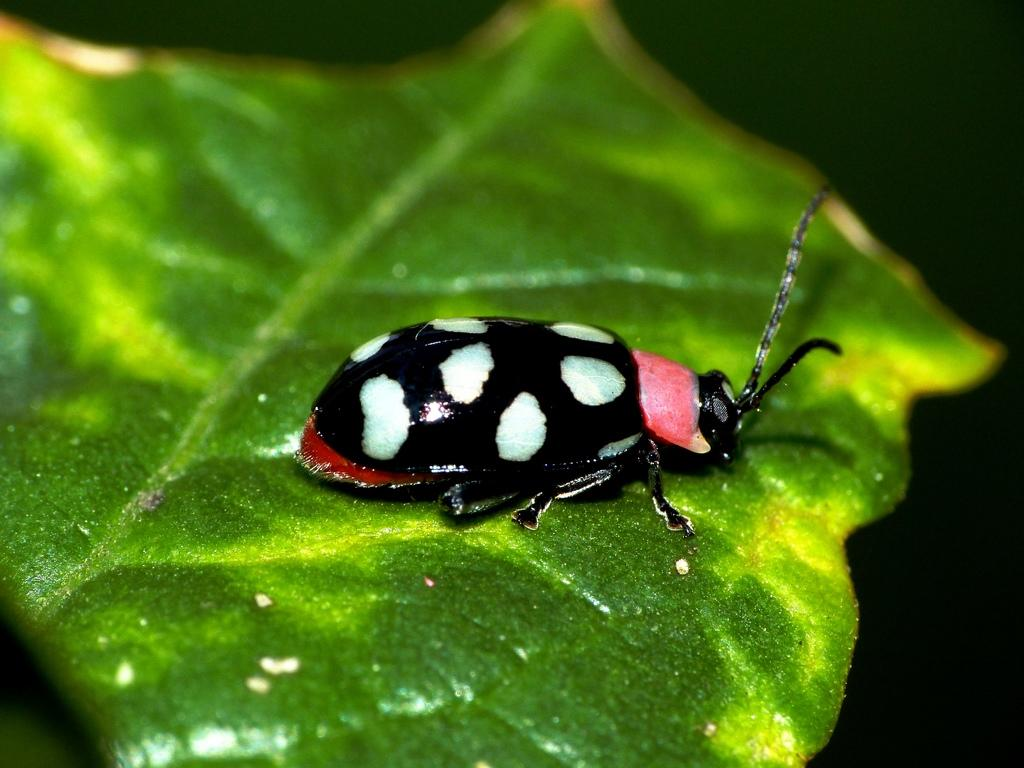What type of creature can be seen in the image? There is an insect in the image. Where is the insect located? The insect is on a leaf. What type of food is the insect eating from the stomach in the image? There is no stomach or food present in the image; the insect is on a leaf. 